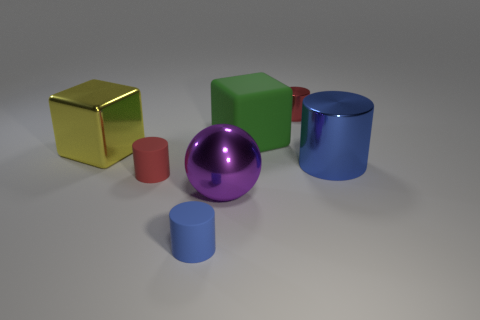Add 1 gray cylinders. How many objects exist? 8 Subtract all cylinders. How many objects are left? 3 Add 4 metallic things. How many metallic things exist? 8 Subtract 0 green balls. How many objects are left? 7 Subtract all large objects. Subtract all metallic blocks. How many objects are left? 2 Add 2 metallic spheres. How many metallic spheres are left? 3 